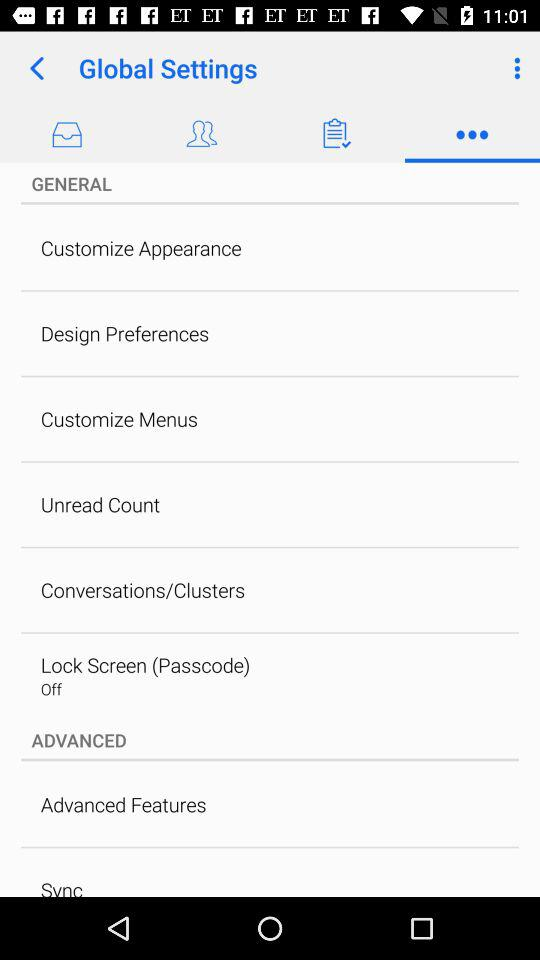What is the status of the lock screen? The status is off. 